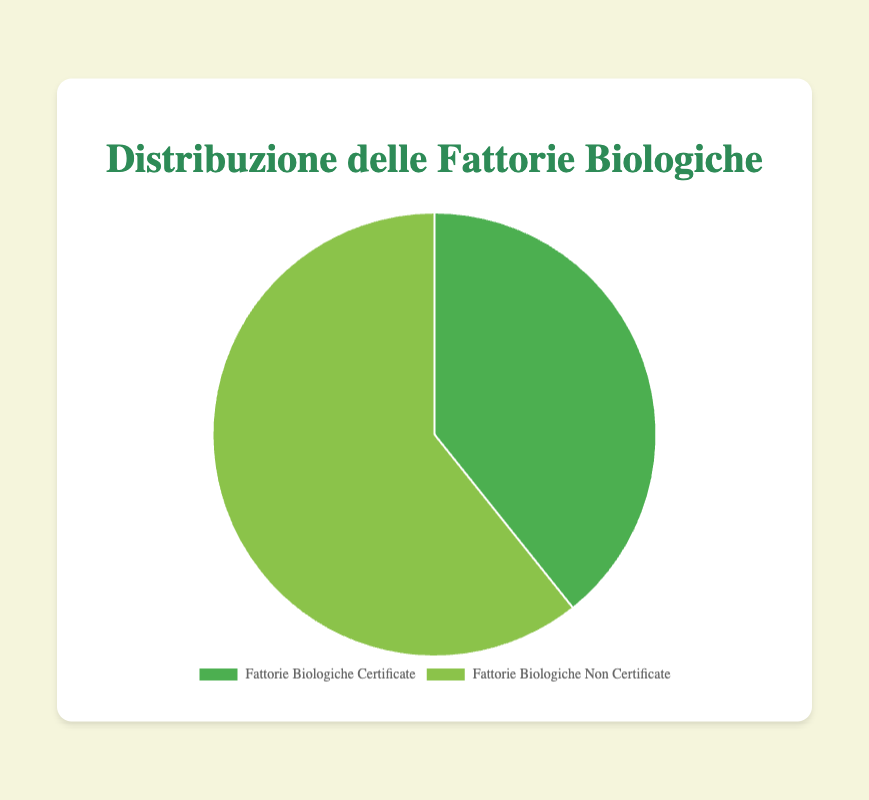What's the percentage of farm sizes accounted for by certified organic farms? The total size for certified organic farms is 1080 ettari and for uncertified organic farms is 1670 ettari. The percentage is calculated by dividing the certified total by the sum of both certified and uncertified, then multiplying by 100: (1080 / (1080 + 1670)) * 100 ≈ 39.3%
Answer: 39.3% Which type of farms occupies a larger portion of the pie chart? Comparing the two portions of the chart visually, uncertified organic farms occupy a larger portion than certified organic farms.
Answer: Uncertified organic farms How many hectares are certified organic farms? Sum the sizes of all certified organic farms: 250 + 150 + 300 + 200 + 180 = 1080 ettari
Answer: 1080 ettari If the uncertified organic farms are divided equally among five entities, what is the average size per entity? Sum the sizes of all uncertified organic farms: 350 + 320 + 400 + 270 + 330 = 1670 ettari. Divide this sum by 5: 1670 / 5 = 334 ettari
Answer: 334 ettari By how many hectares do uncertified organic farms exceed certified organic farms? Uncertified organic farms total 1670 ettari, and certified organic farms total 1080 ettari. Subtract the certified total from the uncertified total: 1670 - 1080 = 590 ettari
Answer: 590 ettari What's the ratio of certified organic to uncertified organic farm sizes? The total size for certified organic farms is 1080 ettari and for uncertified organic farms is 1670 ettari. The ratio is 1080 to 1670, which simplifies to approximately 0.65
Answer: 0.65 Which farm size category has more diversity in individual farm sizes? By comparing individual farm sizes visually, uncertified organic farms have a greater range of sizes (from 270 to 400 ettari) compared to certified organic farms (from 150 to 300 ettari).
Answer: Uncertified organic farms How does the pie chart segment for certified organic farms compare in size visually to that for uncertified organic farms? The pie chart segment for certified organic farms is visually smaller than that for uncertified organic farms, indicating they occupy a lesser percentage of the total farm sizes.
Answer: Smaller What is the combined percentage of certified and uncertified organic farms that are greater than 300 hectares? Only uncertified organic farms have sizes greater than 300 ettari: Pure Fields (400 ettari) and Naturally Grown (330 ettari). The combined sizes are 400 + 330 = 730 ettari. The total farm size is 2750 ettari. The percentage is (730 / 2750) * 100 ≈ 26.5%.
Answer: 26.5% If the pie chart were to be divided into quarters, which type of farm would most likely dominate three quarters? Uncertified organic farms occupy a larger overall portion of the pie chart compared to certified organic farms. Thus, if divided into quarters, uncertified farms would likely dominate three quarters.
Answer: Uncertified organic farms 